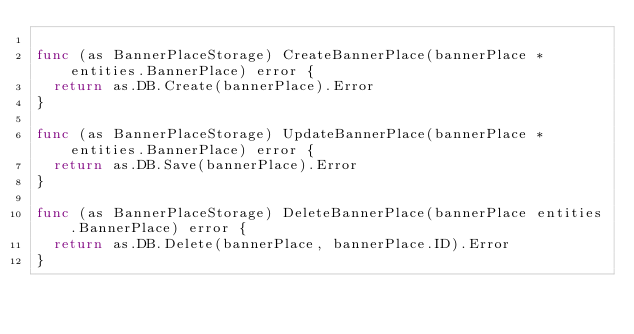Convert code to text. <code><loc_0><loc_0><loc_500><loc_500><_Go_>
func (as BannerPlaceStorage) CreateBannerPlace(bannerPlace *entities.BannerPlace) error {
	return as.DB.Create(bannerPlace).Error
}

func (as BannerPlaceStorage) UpdateBannerPlace(bannerPlace *entities.BannerPlace) error {
	return as.DB.Save(bannerPlace).Error
}

func (as BannerPlaceStorage) DeleteBannerPlace(bannerPlace entities.BannerPlace) error {
	return as.DB.Delete(bannerPlace, bannerPlace.ID).Error
}
</code> 